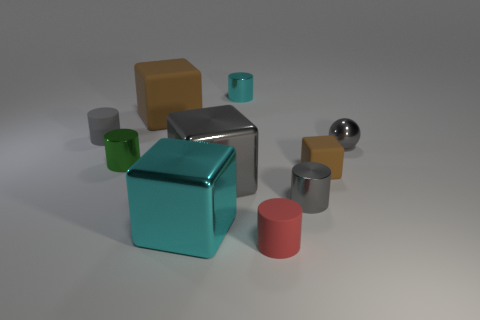What could be a possible use for these objects? These objects could serve an educational purpose, such as teaching about shapes, colors, and materials in a learning environment. They might also be used as decorative items or elements in a design or art installation, given the deliberate composition and aesthetic appeal. 